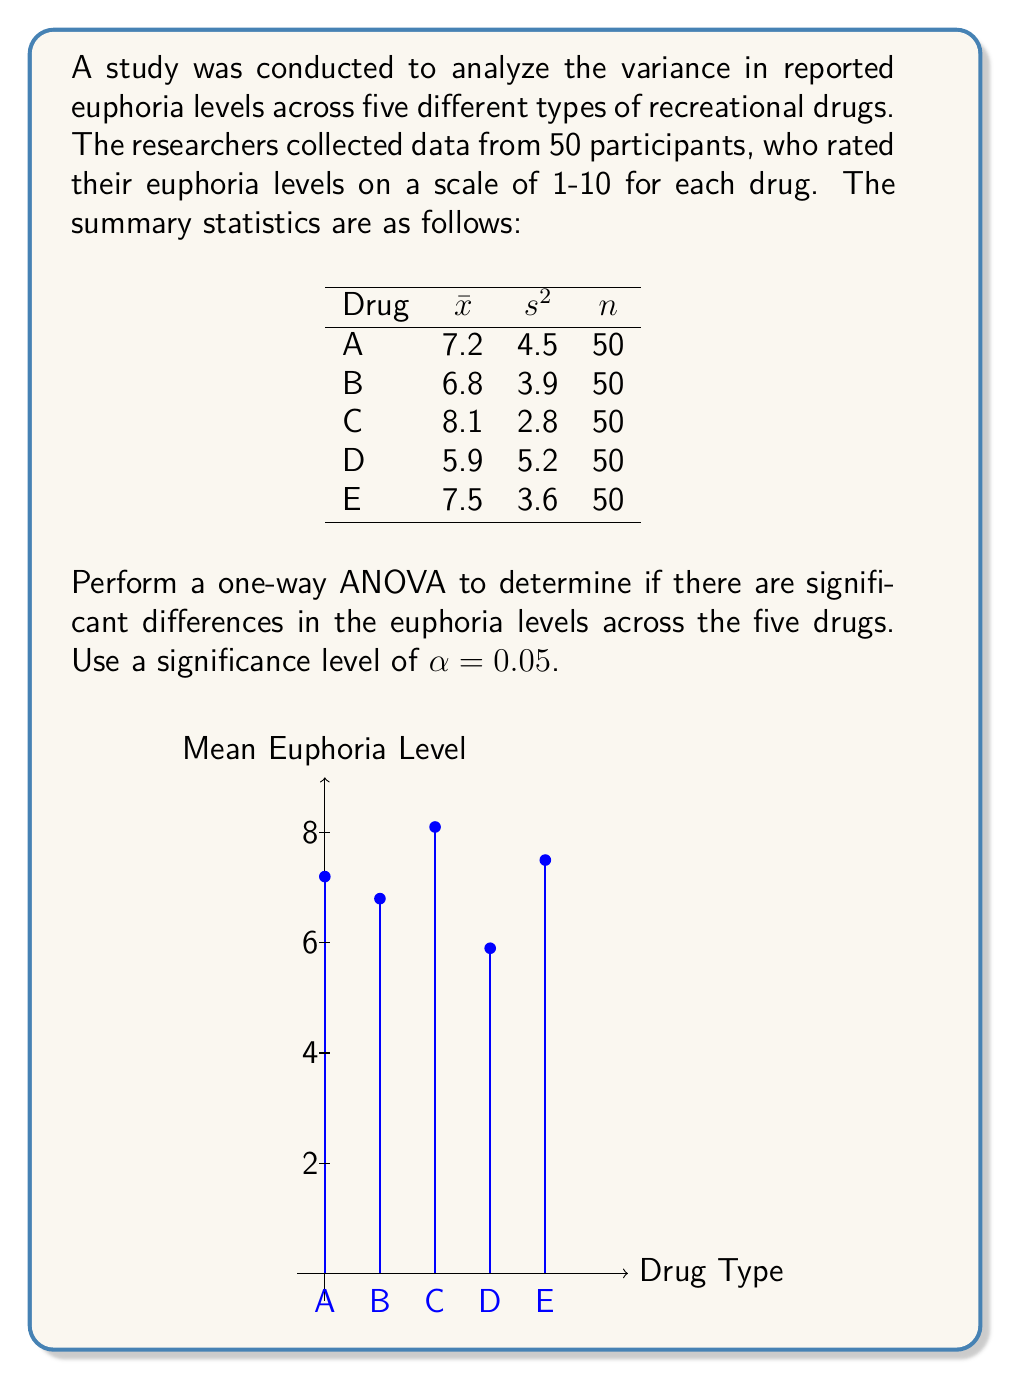Can you answer this question? To perform a one-way ANOVA, we need to follow these steps:

1. Calculate the Grand Mean:
$$\bar{x} = \frac{\sum_{i=1}^{k} n_i \bar{x}_i}{\sum_{i=1}^{k} n_i} = \frac{50(7.2 + 6.8 + 8.1 + 5.9 + 7.5)}{250} = 7.1$$

2. Calculate SSB (Sum of Squares Between groups):
$$SSB = \sum_{i=1}^{k} n_i (\bar{x}_i - \bar{x})^2$$
$$SSB = 50[(7.2-7.1)^2 + (6.8-7.1)^2 + (8.1-7.1)^2 + (5.9-7.1)^2 + (7.5-7.1)^2] = 126.5$$

3. Calculate SSW (Sum of Squares Within groups):
$$SSW = \sum_{i=1}^{k} (n_i - 1)s_i^2$$
$$SSW = 49(4.5 + 3.9 + 2.8 + 5.2 + 3.6) = 980$$

4. Calculate SST (Total Sum of Squares):
$$SST = SSB + SSW = 126.5 + 980 = 1106.5$$

5. Calculate degrees of freedom:
$$df_B = k - 1 = 5 - 1 = 4$$
$$df_W = N - k = 250 - 5 = 245$$
$$df_T = N - 1 = 250 - 1 = 249$$

6. Calculate Mean Square Between (MSB) and Mean Square Within (MSW):
$$MSB = \frac{SSB}{df_B} = \frac{126.5}{4} = 31.625$$
$$MSW = \frac{SSW}{df_W} = \frac{980}{245} = 4$$

7. Calculate F-statistic:
$$F = \frac{MSB}{MSW} = \frac{31.625}{4} = 7.90625$$

8. Find the critical F-value:
For α = 0.05, df_B = 4, and df_W = 245, the critical F-value is approximately 2.41 (from F-distribution table).

9. Compare F-statistic to critical F-value:
Since 7.90625 > 2.41, we reject the null hypothesis.

10. Calculate p-value:
Using an F-distribution calculator, we find that the p-value for F(4, 245) = 7.90625 is approximately 0.000004, which is less than α = 0.05.
Answer: Reject null hypothesis; significant differences exist (F = 7.90625, p < 0.05) 